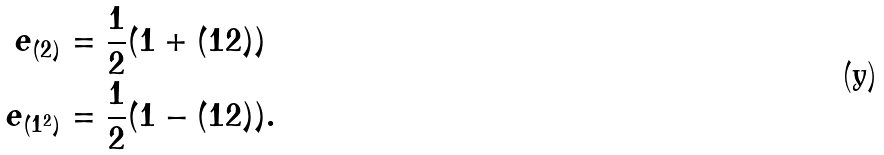Convert formula to latex. <formula><loc_0><loc_0><loc_500><loc_500>e _ { ( 2 ) } & = \frac { 1 } { 2 } ( 1 + ( 1 2 ) ) \\ e _ { ( 1 ^ { 2 } ) } & = \frac { 1 } { 2 } ( 1 - ( 1 2 ) ) .</formula> 